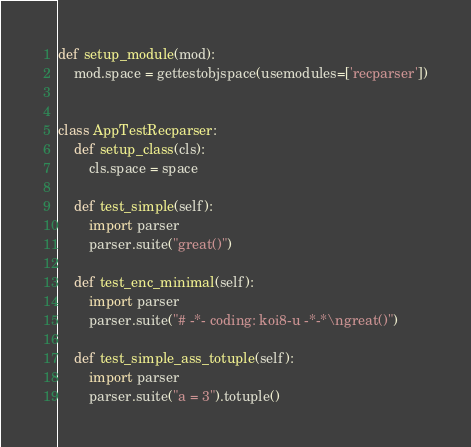<code> <loc_0><loc_0><loc_500><loc_500><_Python_>
def setup_module(mod): 
    mod.space = gettestobjspace(usemodules=['recparser'])


class AppTestRecparser: 
    def setup_class(cls):
        cls.space = space

    def test_simple(self):
        import parser
        parser.suite("great()")

    def test_enc_minimal(self):
        import parser
        parser.suite("# -*- coding: koi8-u -*-*\ngreat()")
        
    def test_simple_ass_totuple(self):
        import parser
        parser.suite("a = 3").totuple()

</code> 